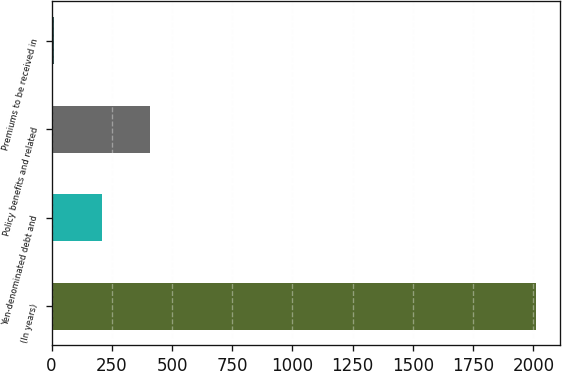Convert chart to OTSL. <chart><loc_0><loc_0><loc_500><loc_500><bar_chart><fcel>(In years)<fcel>Yen-denominated debt and<fcel>Policy benefits and related<fcel>Premiums to be received in<nl><fcel>2009<fcel>209.9<fcel>409.8<fcel>10<nl></chart> 